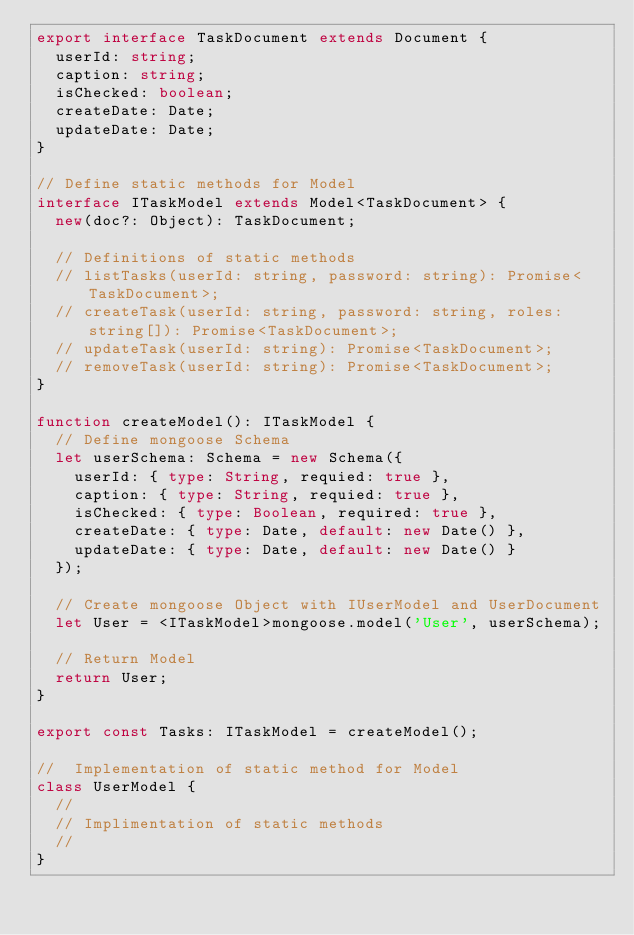<code> <loc_0><loc_0><loc_500><loc_500><_TypeScript_>export interface TaskDocument extends Document {
  userId: string;
  caption: string;
  isChecked: boolean;
  createDate: Date;
  updateDate: Date;
}

// Define static methods for Model
interface ITaskModel extends Model<TaskDocument> {
  new(doc?: Object): TaskDocument;

  // Definitions of static methods
  // listTasks(userId: string, password: string): Promise<TaskDocument>;
  // createTask(userId: string, password: string, roles: string[]): Promise<TaskDocument>;
  // updateTask(userId: string): Promise<TaskDocument>;
  // removeTask(userId: string): Promise<TaskDocument>;
}

function createModel(): ITaskModel {
  // Define mongoose Schema
  let userSchema: Schema = new Schema({
    userId: { type: String, requied: true },
    caption: { type: String, requied: true },
    isChecked: { type: Boolean, required: true },
    createDate: { type: Date, default: new Date() },
    updateDate: { type: Date, default: new Date() }
  });

  // Create mongoose Object with IUserModel and UserDocument
  let User = <ITaskModel>mongoose.model('User', userSchema);

  // Return Model
  return User;
}

export const Tasks: ITaskModel = createModel();

//  Implementation of static method for Model
class UserModel {
  //
  // Implimentation of static methods
  //
}
</code> 